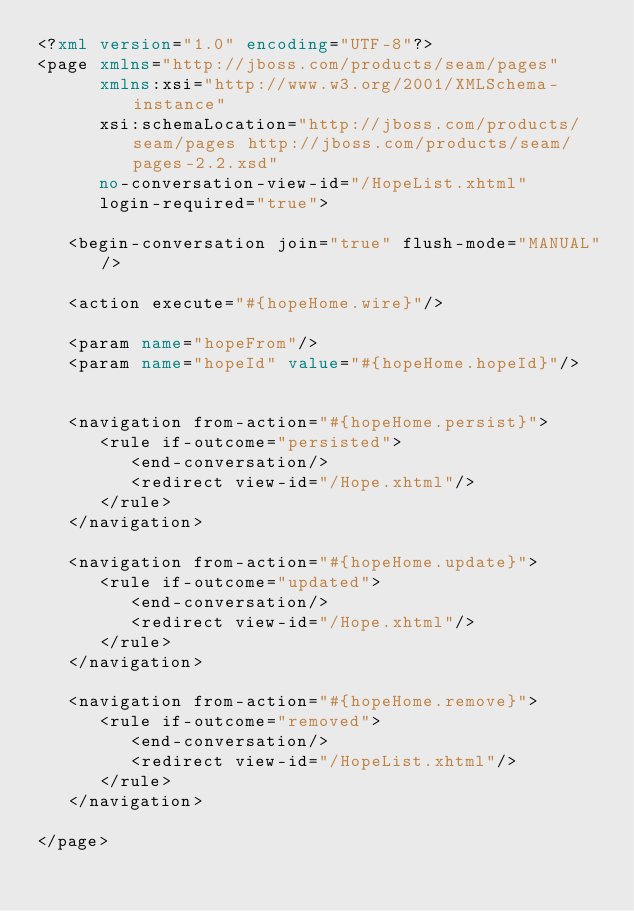Convert code to text. <code><loc_0><loc_0><loc_500><loc_500><_XML_><?xml version="1.0" encoding="UTF-8"?>
<page xmlns="http://jboss.com/products/seam/pages"
      xmlns:xsi="http://www.w3.org/2001/XMLSchema-instance"
      xsi:schemaLocation="http://jboss.com/products/seam/pages http://jboss.com/products/seam/pages-2.2.xsd"
      no-conversation-view-id="/HopeList.xhtml"
      login-required="true">

   <begin-conversation join="true" flush-mode="MANUAL"/>

   <action execute="#{hopeHome.wire}"/>

   <param name="hopeFrom"/>
   <param name="hopeId" value="#{hopeHome.hopeId}"/>


   <navigation from-action="#{hopeHome.persist}">
      <rule if-outcome="persisted">
         <end-conversation/>
         <redirect view-id="/Hope.xhtml"/>
      </rule>
   </navigation>

   <navigation from-action="#{hopeHome.update}">
      <rule if-outcome="updated">
         <end-conversation/>
         <redirect view-id="/Hope.xhtml"/>
      </rule>
   </navigation>

   <navigation from-action="#{hopeHome.remove}">
      <rule if-outcome="removed">
         <end-conversation/>
         <redirect view-id="/HopeList.xhtml"/>
      </rule>
   </navigation>

</page>
</code> 